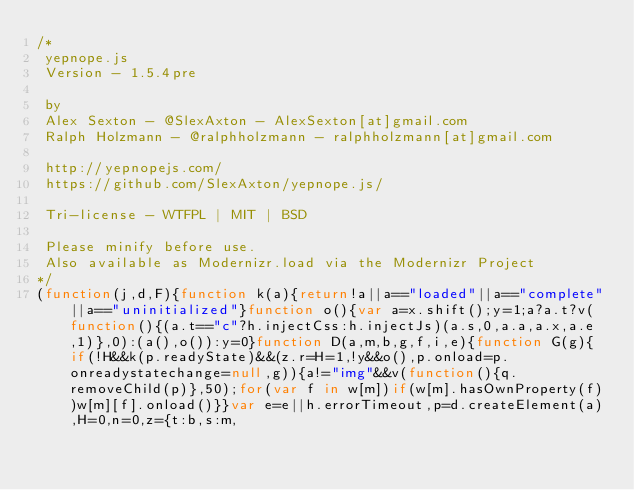<code> <loc_0><loc_0><loc_500><loc_500><_JavaScript_>/*
 yepnope.js
 Version - 1.5.4pre

 by
 Alex Sexton - @SlexAxton - AlexSexton[at]gmail.com
 Ralph Holzmann - @ralphholzmann - ralphholzmann[at]gmail.com

 http://yepnopejs.com/
 https://github.com/SlexAxton/yepnope.js/

 Tri-license - WTFPL | MIT | BSD

 Please minify before use.
 Also available as Modernizr.load via the Modernizr Project
*/
(function(j,d,F){function k(a){return!a||a=="loaded"||a=="complete"||a=="uninitialized"}function o(){var a=x.shift();y=1;a?a.t?v(function(){(a.t=="c"?h.injectCss:h.injectJs)(a.s,0,a.a,a.x,a.e,1)},0):(a(),o()):y=0}function D(a,m,b,g,f,i,e){function G(g){if(!H&&k(p.readyState)&&(z.r=H=1,!y&&o(),p.onload=p.onreadystatechange=null,g)){a!="img"&&v(function(){q.removeChild(p)},50);for(var f in w[m])if(w[m].hasOwnProperty(f))w[m][f].onload()}}var e=e||h.errorTimeout,p=d.createElement(a),H=0,n=0,z={t:b,s:m,</code> 